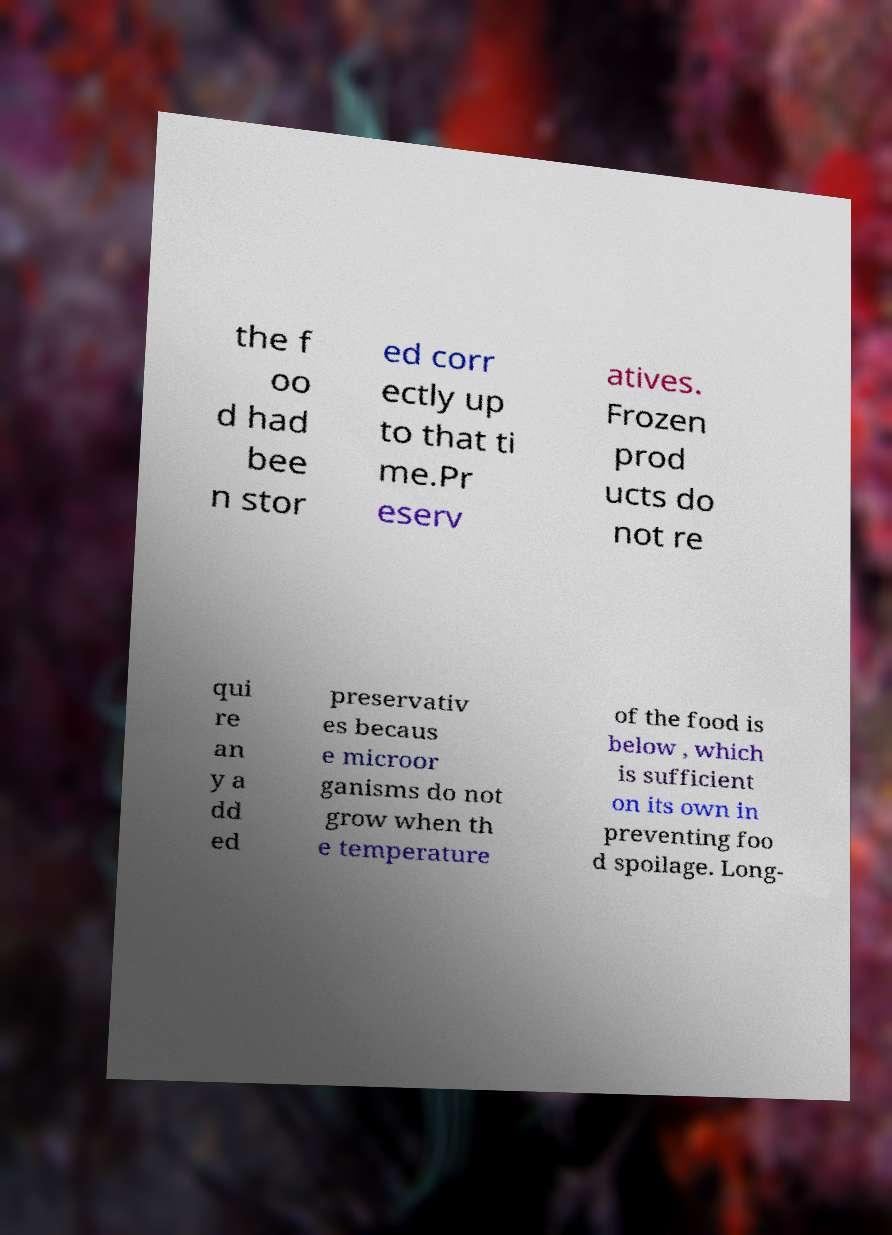Please identify and transcribe the text found in this image. the f oo d had bee n stor ed corr ectly up to that ti me.Pr eserv atives. Frozen prod ucts do not re qui re an y a dd ed preservativ es becaus e microor ganisms do not grow when th e temperature of the food is below , which is sufficient on its own in preventing foo d spoilage. Long- 